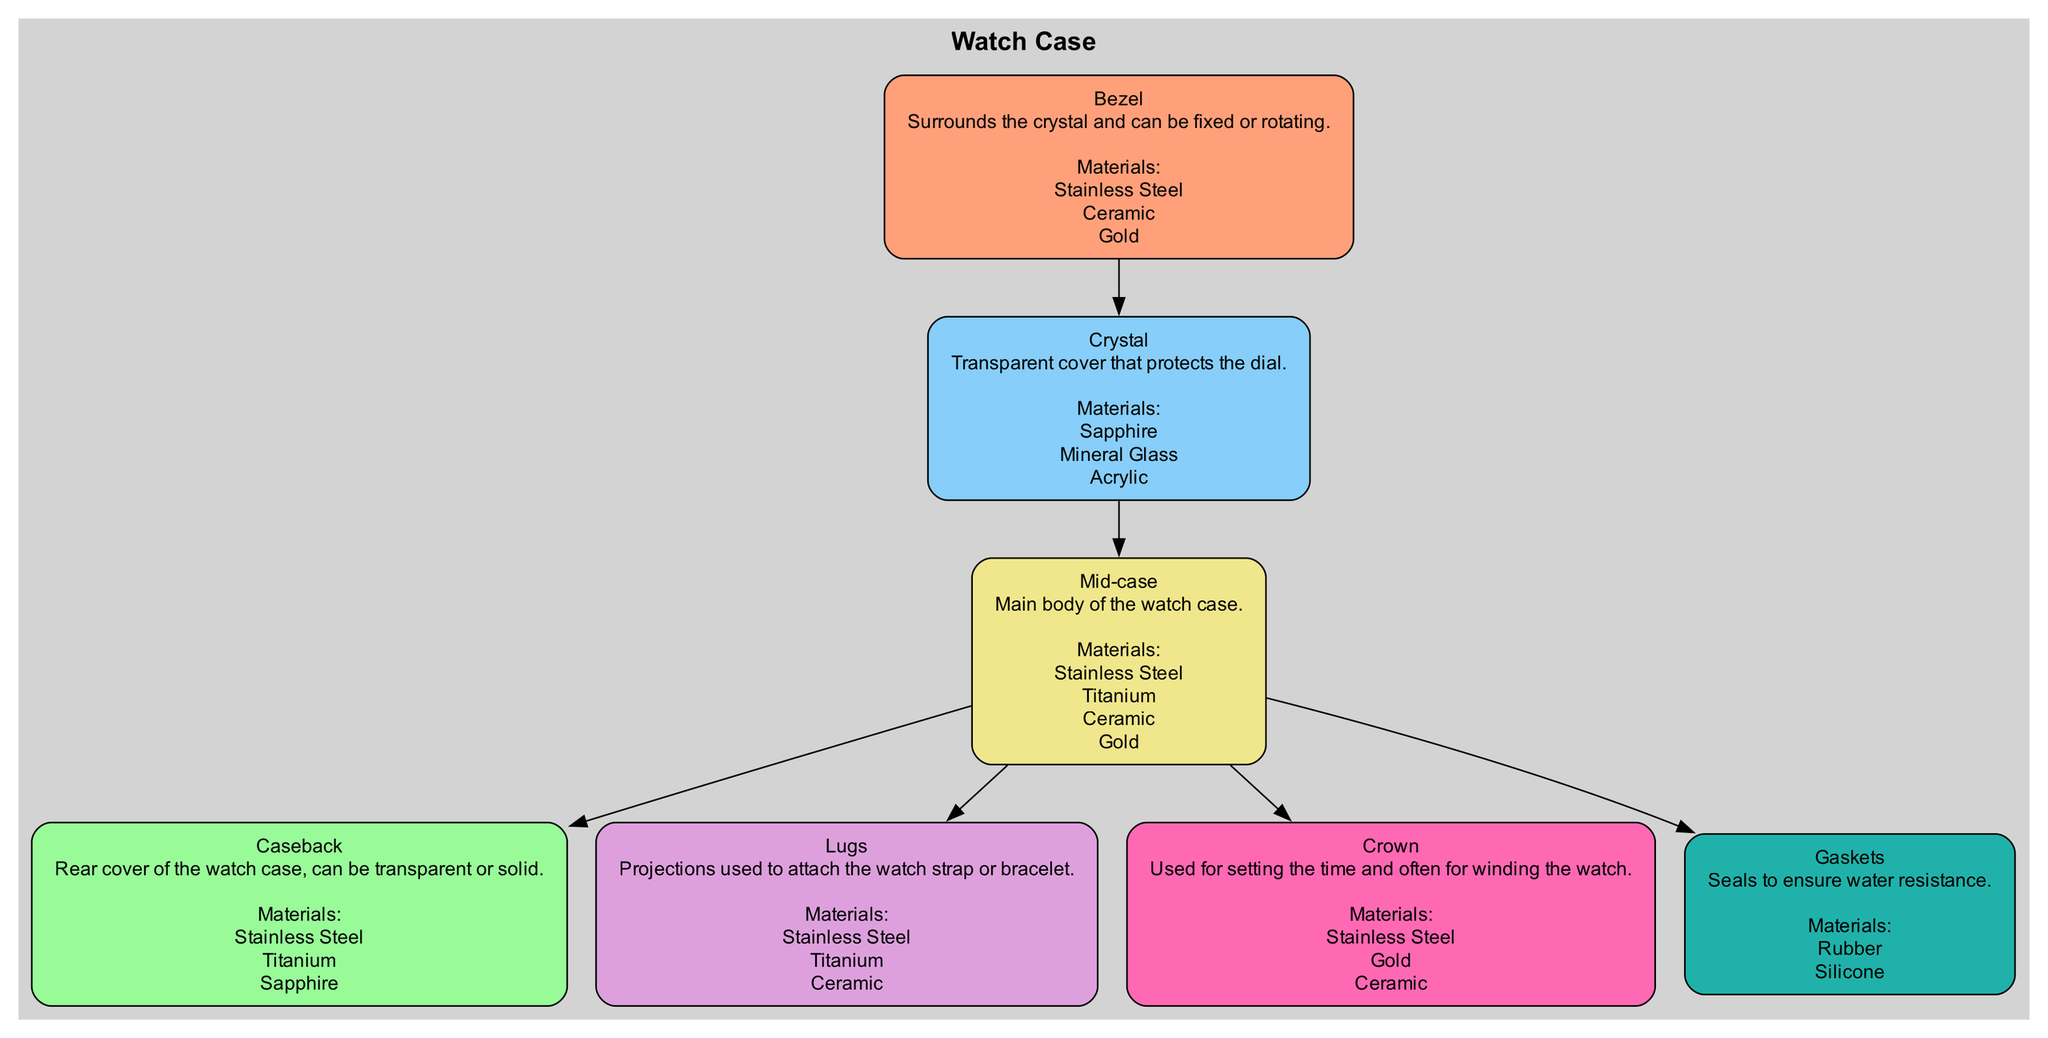What is the function of the crown? The crown is used for setting the time and often for winding the watch. This information is explicitly mentioned in the description associated with the crown node in the diagram.
Answer: Setting time How many materials are listed for the bezel? The materials listed for the bezel are stainless steel, ceramic, and gold. Counting these, we find there are three materials mentioned.
Answer: 3 Which element is directly connected to the caseback? The caseback is directly connected to the mid-case, as indicated by the edge connecting these two nodes in the diagram.
Answer: Mid-case What material is used for gaskets? The materials listed for gaskets are rubber and silicone. This can be directly found in the materials section of the gaskets node.
Answer: Rubber, Silicone Which elements can be made from titanium? The elements that can be made from titanium are the caseback, lugs, and mid-case. By reviewing the materials for each element in the diagram, we can identify these nodes.
Answer: Caseback, Lugs, Mid-case What connects the bezel and the crystal? The bezel is connected to the crystal by a direct edge in the flow of the diagram, indicating a direct relationship.
Answer: Crystal How many elements are there in the diagram? There are seven elements outlined in the diagram: bezel, crystal, caseback, lugs, mid-case, crown, and gaskets. Counting these gives us the total number of elements.
Answer: 7 Which element is described as having a transparent cover? The element that is described as having a transparent cover is the crystal. This is mentioned in the crystal's description in the diagram.
Answer: Crystal What is the primary material of the mid-case? The mid-case is made from stainless steel, titanium, ceramic, and gold, which are all explicitly listed under its materials section in the diagram.
Answer: Stainless Steel, Titanium, Ceramic, Gold 